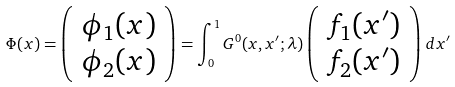<formula> <loc_0><loc_0><loc_500><loc_500>\Phi ( x ) = \left ( \begin{array} { c } \phi _ { 1 } ( x ) \\ \phi _ { 2 } ( x ) \end{array} \right ) = \int _ { 0 } ^ { 1 } G ^ { 0 } ( x , x ^ { \prime } ; \lambda ) \left ( \begin{array} { c } f _ { 1 } ( x ^ { \prime } ) \\ f _ { 2 } ( x ^ { \prime } ) \end{array} \right ) \, d x ^ { \prime }</formula> 